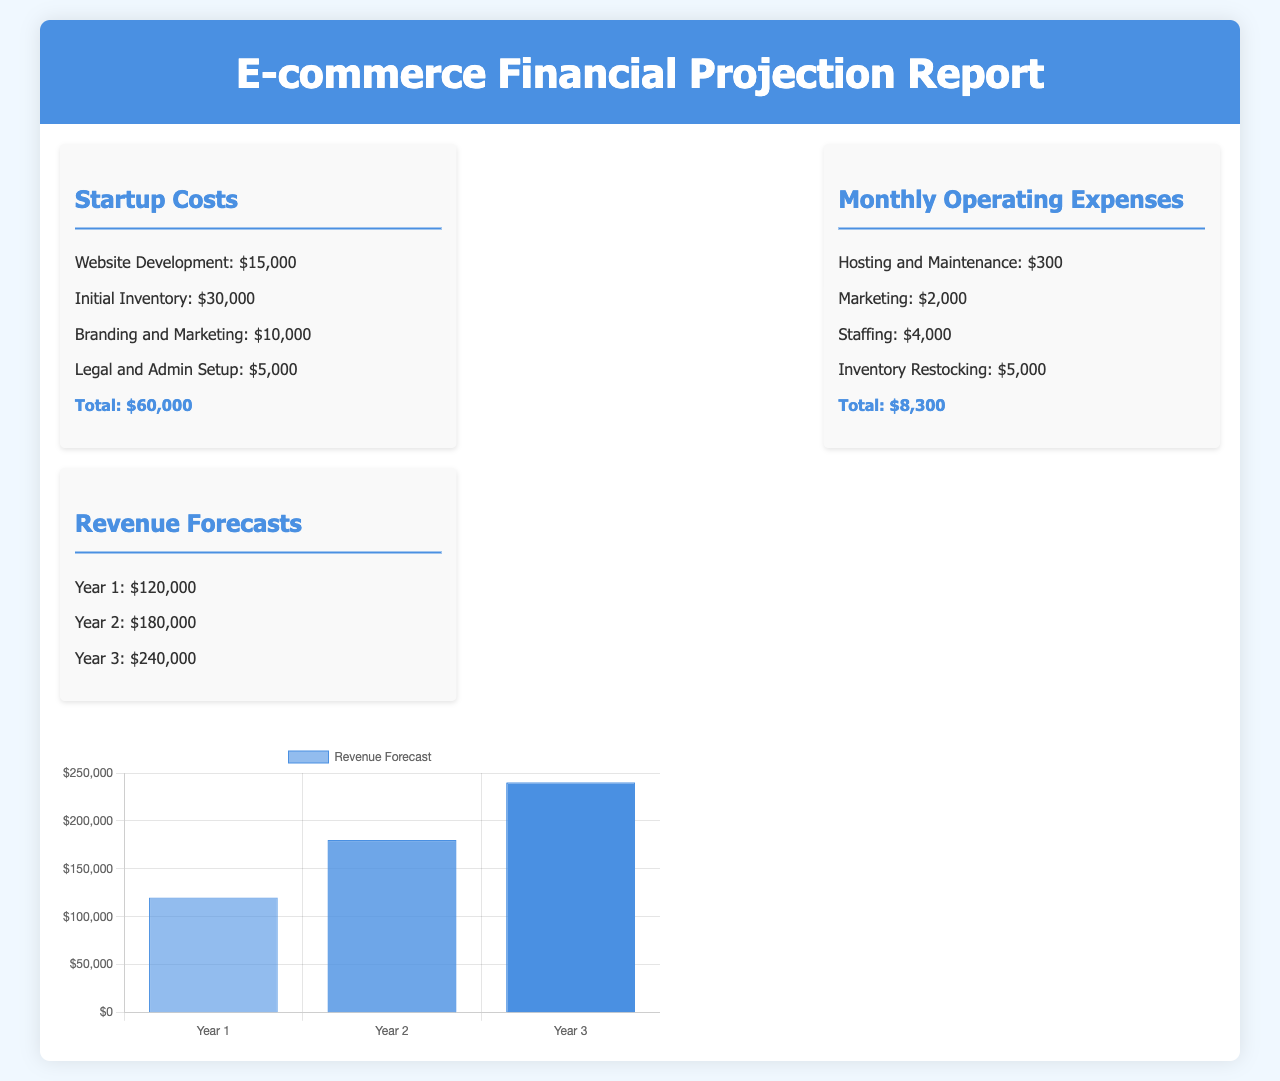What are the startup costs? The startup costs are listed in the document as individual expenses which total $60,000.
Answer: $60,000 What is the monthly operating expense for marketing? The document specifies the monthly operating expense for marketing as $2,000.
Answer: $2,000 What is the initial inventory cost? The initial inventory cost is detailed in the document as $30,000.
Answer: $30,000 What is the revenue forecast for Year 2? The document states the revenue forecast for Year 2 is $180,000.
Answer: $180,000 How much is spent on staffing monthly? The monthly expense for staffing, as indicated in the document, is $4,000.
Answer: $4,000 What is the difference in revenue between Year 3 and Year 1? The revenue for Year 3 is $240,000 and for Year 1 is $120,000; the difference can be calculated as $240,000 - $120,000 = $120,000.
Answer: $120,000 What is included in the legal and admin setup costs? The document outlines legal and admin setup costs as part of total startup costs but does not itemize specifics.
Answer: Not specified What is the total monthly operating expense? The total monthly operating expenses calculated from the document are $8,300.
Answer: $8,300 How are the revenue forecasts presented in the document? The revenue forecasts are presented in a structured list for each of the three years.
Answer: Structured list 